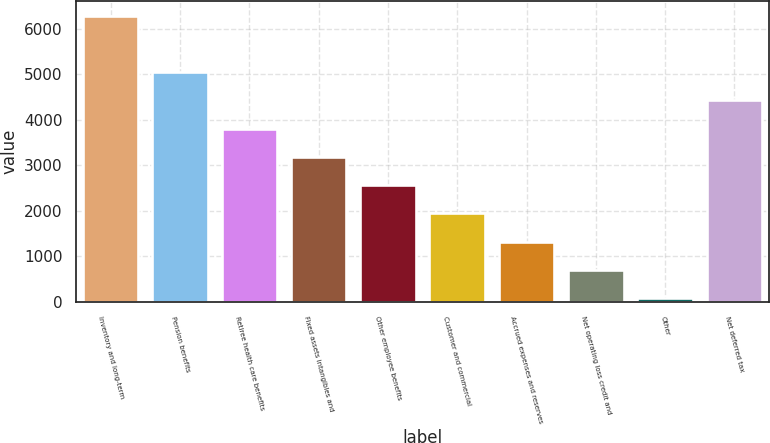Convert chart to OTSL. <chart><loc_0><loc_0><loc_500><loc_500><bar_chart><fcel>Inventory and long-term<fcel>Pension benefits<fcel>Retiree health care benefits<fcel>Fixed assets intangibles and<fcel>Other employee benefits<fcel>Customer and commercial<fcel>Accrued expenses and reserves<fcel>Net operating loss credit and<fcel>Other<fcel>Net deferred tax<nl><fcel>6290<fcel>5048.4<fcel>3806.8<fcel>3186<fcel>2565.2<fcel>1944.4<fcel>1323.6<fcel>702.8<fcel>82<fcel>4427.6<nl></chart> 